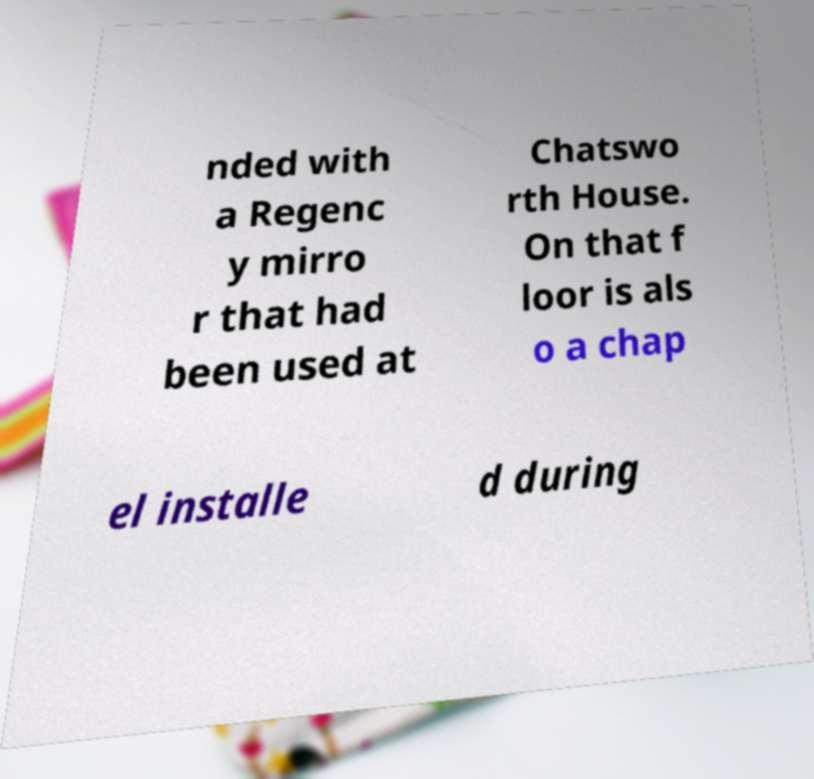Please read and relay the text visible in this image. What does it say? nded with a Regenc y mirro r that had been used at Chatswo rth House. On that f loor is als o a chap el installe d during 